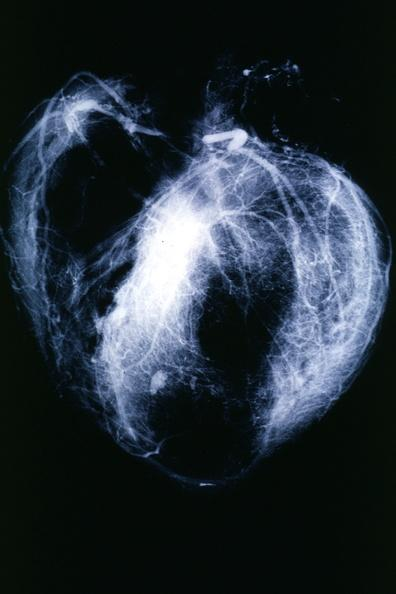what does this image show?
Answer the question using a single word or phrase. Postmortangiogram with apparent lesions in proximal right coronary 